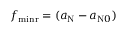Convert formula to latex. <formula><loc_0><loc_0><loc_500><loc_500>f _ { \min r } = ( a _ { N } - a _ { N 0 } )</formula> 